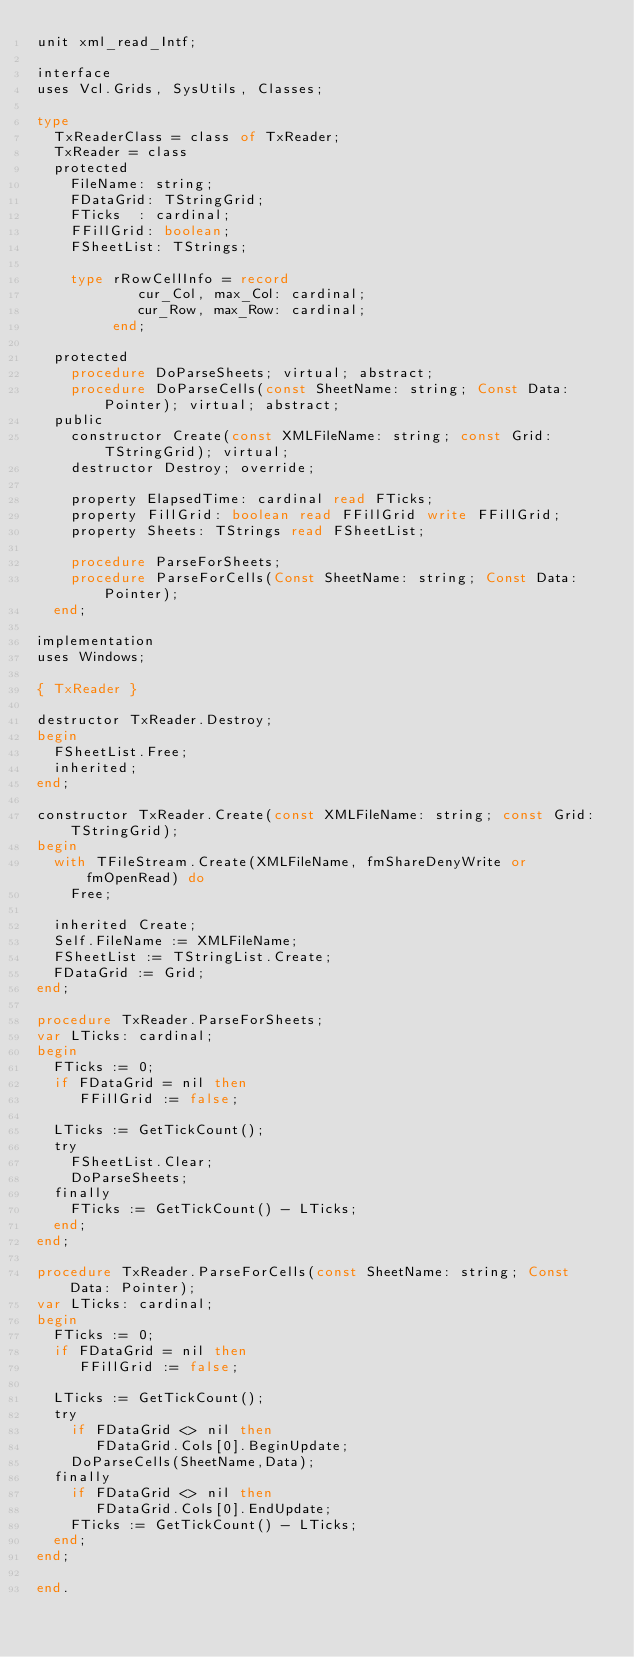Convert code to text. <code><loc_0><loc_0><loc_500><loc_500><_Pascal_>unit xml_read_Intf;

interface
uses Vcl.Grids, SysUtils, Classes;

type
  TxReaderClass = class of TxReader;
  TxReader = class
  protected
    FileName: string;
    FDataGrid: TStringGrid;
    FTicks  : cardinal;
    FFillGrid: boolean;
    FSheetList: TStrings;

    type rRowCellInfo = record
            cur_Col, max_Col: cardinal;
            cur_Row, max_Row: cardinal;
         end;

  protected
    procedure DoParseSheets; virtual; abstract;
    procedure DoParseCells(const SheetName: string; Const Data: Pointer); virtual; abstract;
  public
    constructor Create(const XMLFileName: string; const Grid: TStringGrid); virtual;
    destructor Destroy; override;

    property ElapsedTime: cardinal read FTicks;
    property FillGrid: boolean read FFillGrid write FFillGrid;
    property Sheets: TStrings read FSheetList;

    procedure ParseForSheets;
    procedure ParseForCells(Const SheetName: string; Const Data: Pointer);
  end;

implementation
uses Windows;

{ TxReader }

destructor TxReader.Destroy;
begin
  FSheetList.Free;
  inherited;
end;

constructor TxReader.Create(const XMLFileName: string; const Grid: TStringGrid);
begin
  with TFileStream.Create(XMLFileName, fmShareDenyWrite or fmOpenRead) do
    Free;

  inherited Create;
  Self.FileName := XMLFileName;
  FSheetList := TStringList.Create;
  FDataGrid := Grid;
end;

procedure TxReader.ParseForSheets;
var LTicks: cardinal;
begin
  FTicks := 0;
  if FDataGrid = nil then
     FFillGrid := false;

  LTicks := GetTickCount();
  try
    FSheetList.Clear;
    DoParseSheets;
  finally
    FTicks := GetTickCount() - LTicks;
  end;
end;

procedure TxReader.ParseForCells(const SheetName: string; Const Data: Pointer);
var LTicks: cardinal;
begin
  FTicks := 0;
  if FDataGrid = nil then
     FFillGrid := false;

  LTicks := GetTickCount();
  try
    if FDataGrid <> nil then
       FDataGrid.Cols[0].BeginUpdate;
    DoParseCells(SheetName,Data);
  finally
    if FDataGrid <> nil then
       FDataGrid.Cols[0].EndUpdate;
    FTicks := GetTickCount() - LTicks;
  end;
end;

end.
</code> 